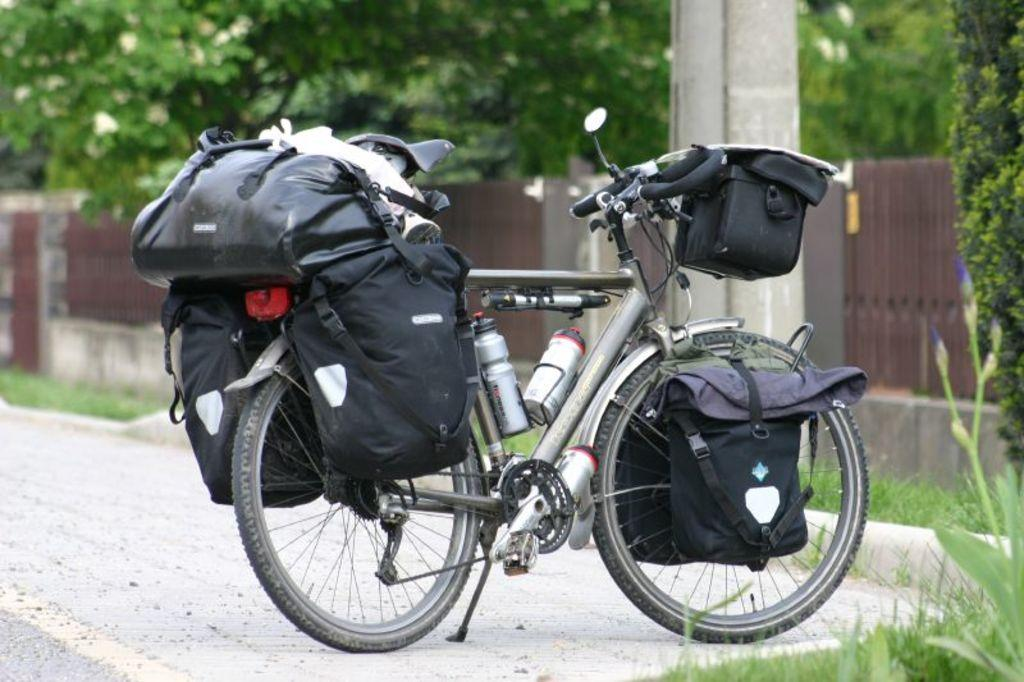What is the main subject of the image? The main subject of the image is a bicycle. Are there any additional items on the bicycle? Yes, there are objects on the bicycle, including luggage. What can be seen in the background of the image? There are trees in the background of the image. What type of soap is being used to clean the bicycle's action in the image? There is no soap or cleaning action visible in the image; it only shows a bicycle with objects and luggage on it, and trees in the background. 